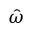<formula> <loc_0><loc_0><loc_500><loc_500>\hat { \omega }</formula> 